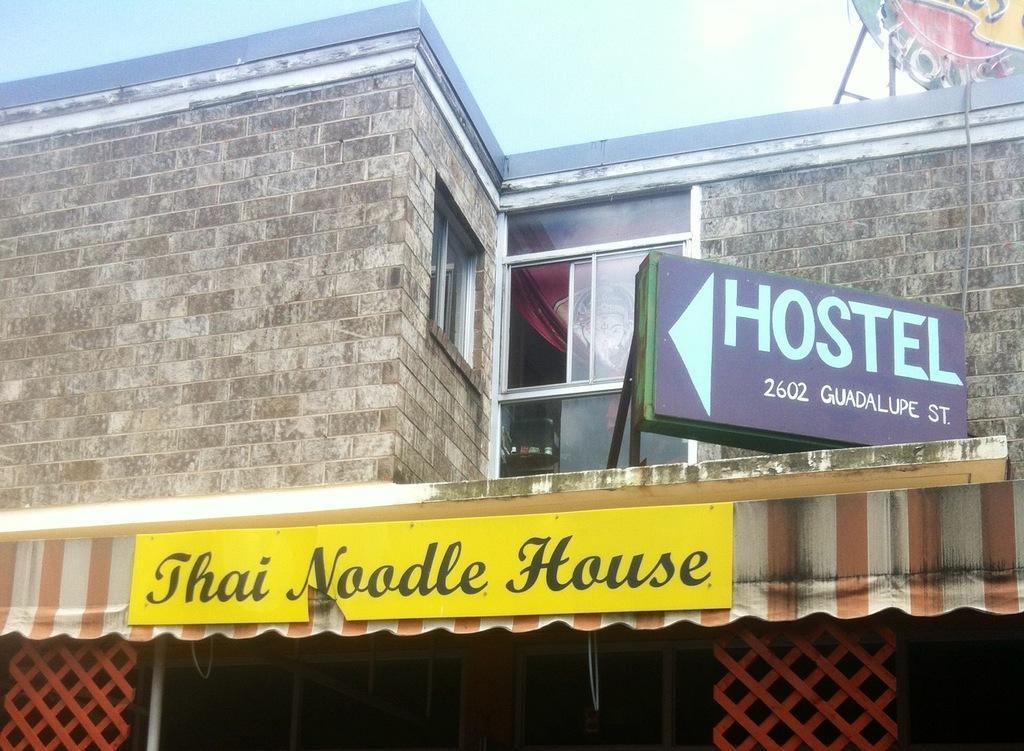Can you describe this image briefly? In this picture I can see hoarding on the right side. I can see glass windows. 